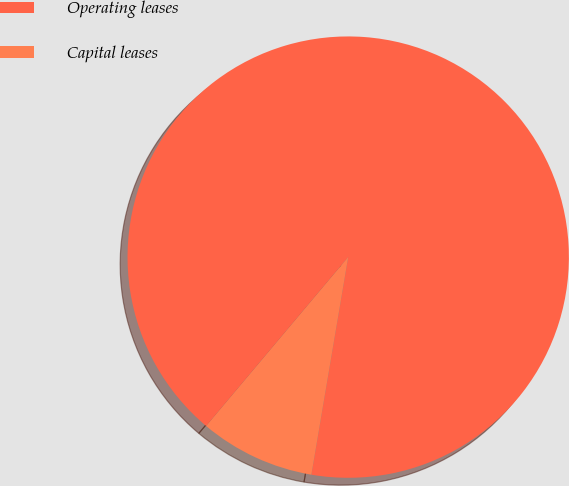Convert chart. <chart><loc_0><loc_0><loc_500><loc_500><pie_chart><fcel>Operating leases<fcel>Capital leases<nl><fcel>91.54%<fcel>8.46%<nl></chart> 